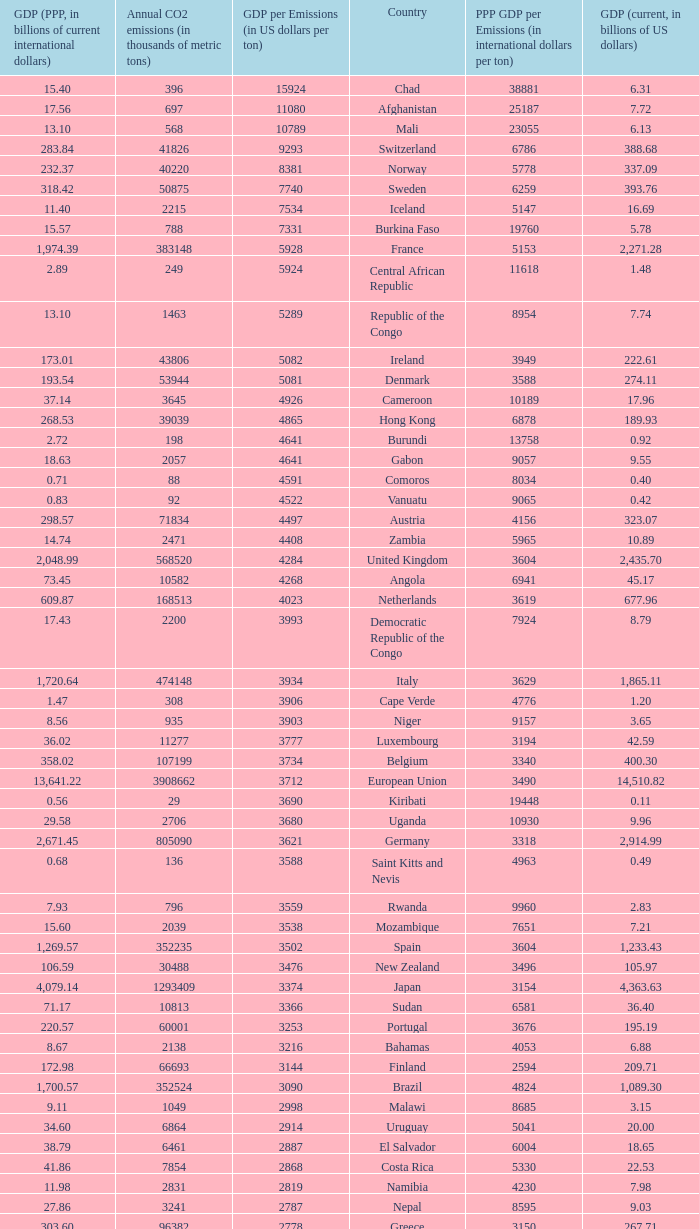When the gdp per emissions (in us dollars per ton) is 3903, what is the maximum annual co2 emissions (in thousands of metric tons)? 935.0. 